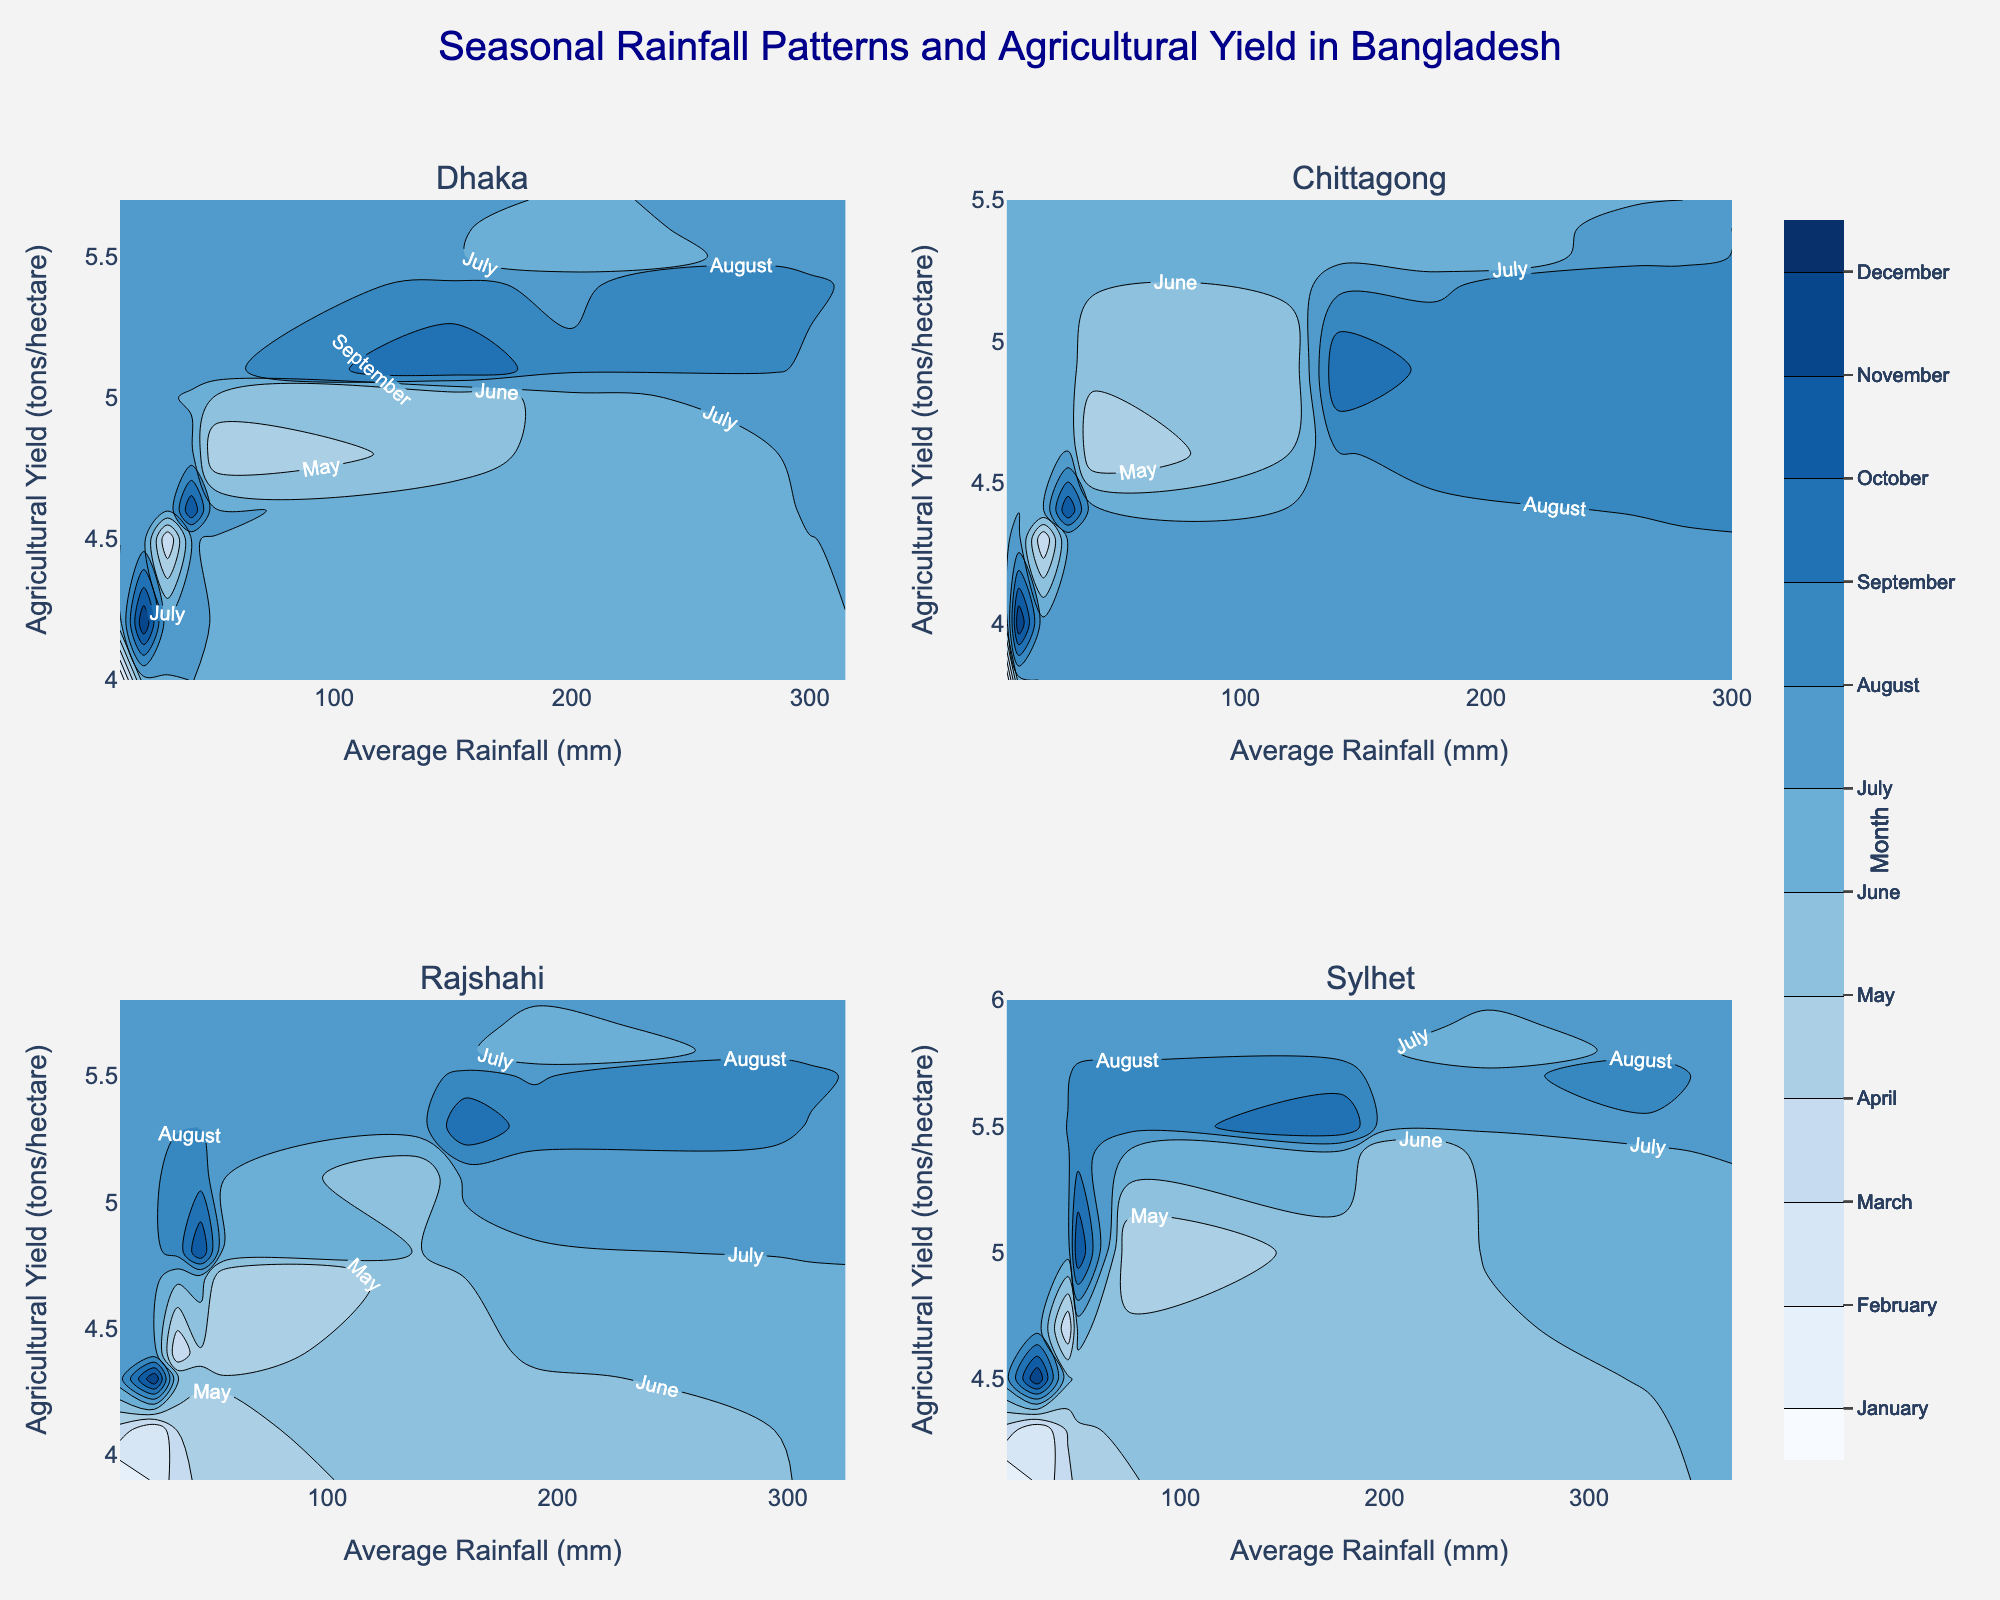**Question 1:** What does the title of the figure say? The title at the top of the figure reads "Seasonal Rainfall Patterns and Agricultural Yield in Bangladesh." This title provides an overall purpose of the figure, indicating it shows how rainfall affects agricultural yield over different seasons in Bangladesh.
Answer: Seasonal Rainfall Patterns and Agricultural Yield in Bangladesh **Question 2:** Which region has the highest maximum average rainfall recorded in any month? By examining the different subplots, the region with the highest maximum average rainfall recorded in any month appears to be Sylhet, with a peak around 370 mm.
Answer: Sylhet **Question 3:** In which month does Dhaka region experience its highest agricultural yield, and what is the yield? To determine this, look at the contour plot for Dhaka. The highest point on the y-axis corresponds to July, where the yield reaches approximately 5.7 tons/hectare.
Answer: July, 5.7 tons/hectare **Question 4:** How does the agricultural yield in Chittagong in March compare to that in November? In Chittagong's contour plot, find the yield values for March and November. In March, the yield is approximately 4.3 tons/hectare, whereas in November, it is around 4.4 tons/hectare. Hence, the yield in November is slightly higher than in March.
Answer: November is slightly higher **Question 5:** What is the overall trend of average rainfall vs. agricultural yield in Rajshahi? The trend in the Rajshahi subplot shows that as average rainfall increases, agricultural yield also generally increases, peaking around July and August and then declining as rainfall decreases.
Answer: Yield increases with rainfall **Question 6:** For which months do all four regions show the lowest agricultural yield? Identify the month with the lowest values on the y-axis across all subplots. January appears to uniformly have lower yields across all regions compared to other months.
Answer: January **Question 7:** What colors are used to represent the start and end of the contours corresponding to months? The colors range from light blue for the start (early months) to dark blue for the end (later months) as per the custom colorscale. This helps to visually distinguish the months on the plot.
Answer: Light blue to dark blue **Question 8:** How does the variation in average rainfall affect the agricultural yield in Sylhet from May to August? Observing the Sylhet subplot, as average rainfall increases from May (200mm) to its peak in August (370mm), the agricultural yield also initially rises but then starts to slightly decline after peaking in July at about 6.0 tons/hectare.
Answer: Increases then slightly decreases **Question 9:** Are there any regions where agricultural yield remains relatively stable despite the increase in average rainfall? The Dhaka region shows relatively stable yields from April to August, where despite significant changes in rainfall, the yield only varies between 4.8 and 5.7 tons/hectare.
Answer: Dhaka **Question 10:** If you were planning agricultural activities for the Rajshahi region, in which month would you expect the highest yield and how much rainfall would you need to consider? Looking at the Rajshahi subplot, the highest yield is in July, where the yield reaches 5.8 tons/hectare, with an average rainfall of around 310 mm.
Answer: July, 310 mm 